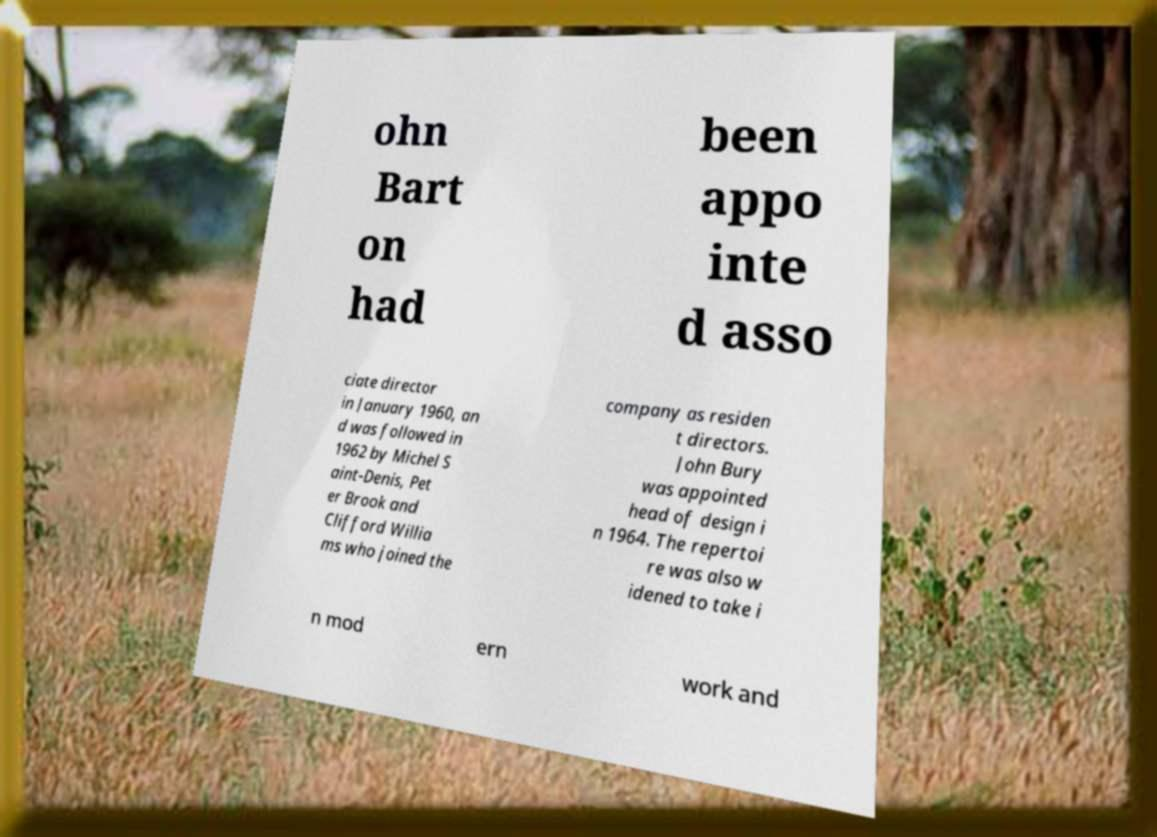Please identify and transcribe the text found in this image. ohn Bart on had been appo inte d asso ciate director in January 1960, an d was followed in 1962 by Michel S aint-Denis, Pet er Brook and Clifford Willia ms who joined the company as residen t directors. John Bury was appointed head of design i n 1964. The repertoi re was also w idened to take i n mod ern work and 